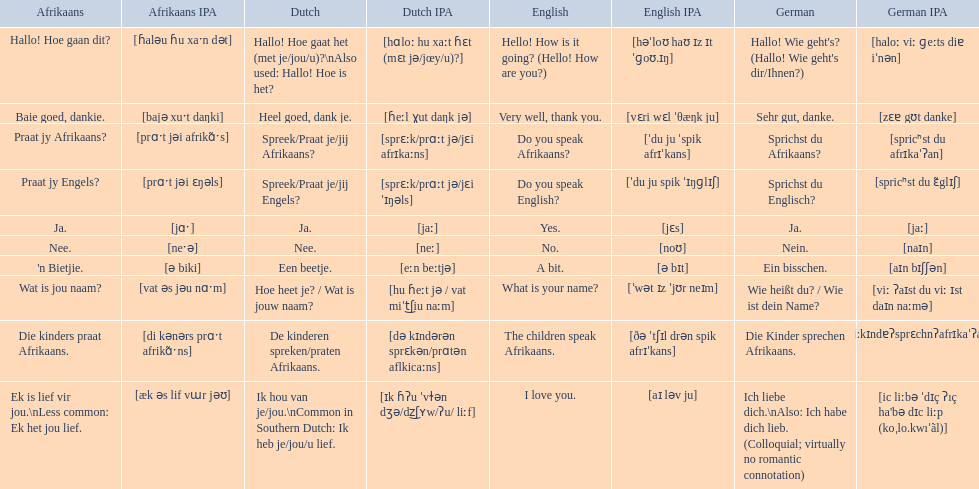What are the listed afrikaans phrases? Hallo! Hoe gaan dit?, Baie goed, dankie., Praat jy Afrikaans?, Praat jy Engels?, Ja., Nee., 'n Bietjie., Wat is jou naam?, Die kinders praat Afrikaans., Ek is lief vir jou.\nLess common: Ek het jou lief. Which is die kinders praat afrikaans? Die kinders praat Afrikaans. What is its german translation? Die Kinder sprechen Afrikaans. 